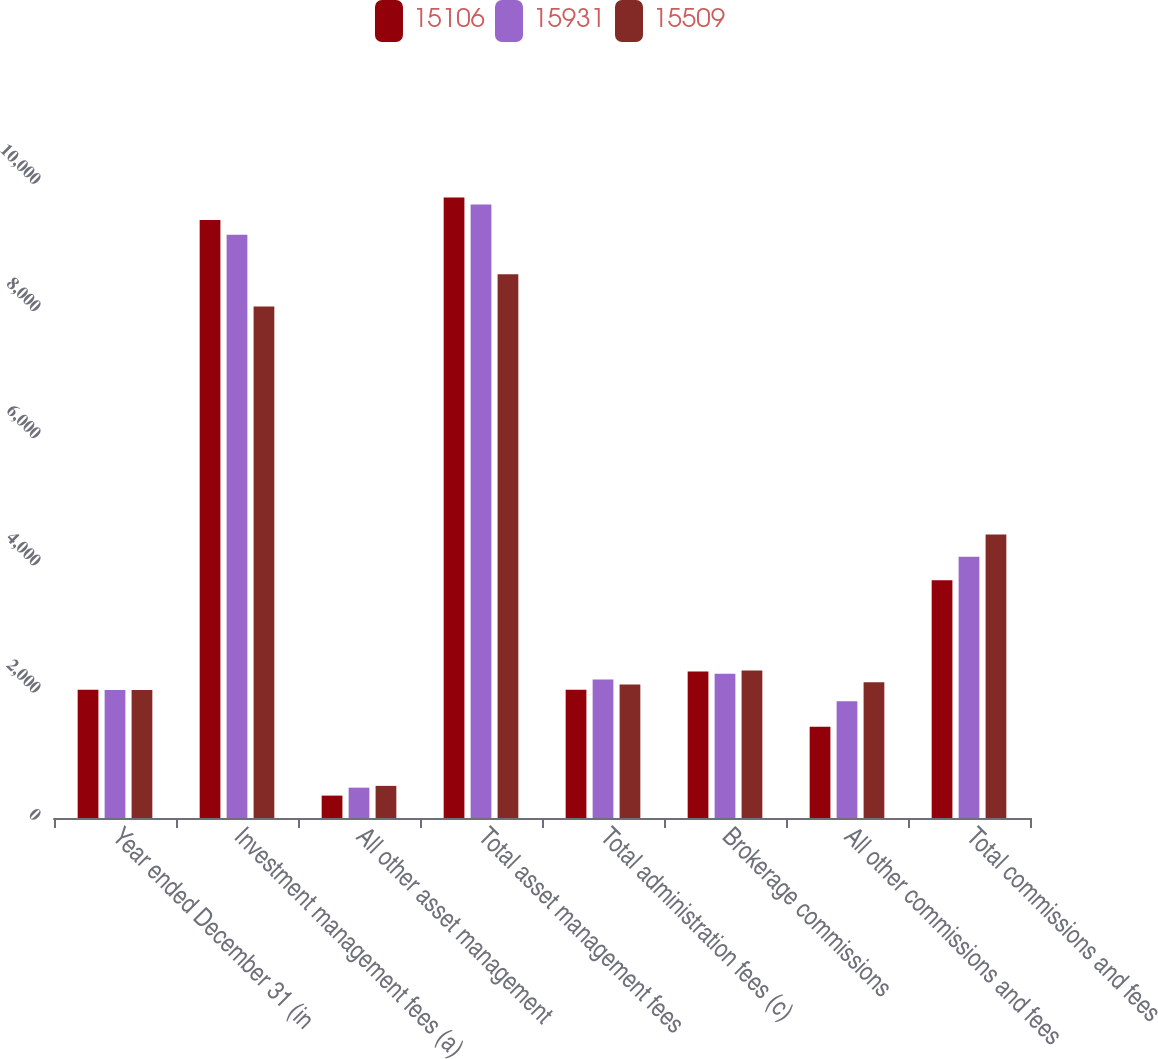Convert chart. <chart><loc_0><loc_0><loc_500><loc_500><stacked_bar_chart><ecel><fcel>Year ended December 31 (in<fcel>Investment management fees (a)<fcel>All other asset management<fcel>Total asset management fees<fcel>Total administration fees (c)<fcel>Brokerage commissions<fcel>All other commissions and fees<fcel>Total commissions and fees<nl><fcel>15106<fcel>2015<fcel>9403<fcel>352<fcel>9755<fcel>2015<fcel>2304<fcel>1435<fcel>3739<nl><fcel>15931<fcel>2014<fcel>9169<fcel>477<fcel>9646<fcel>2179<fcel>2270<fcel>1836<fcel>4106<nl><fcel>15509<fcel>2013<fcel>8044<fcel>505<fcel>8549<fcel>2101<fcel>2321<fcel>2135<fcel>4456<nl></chart> 